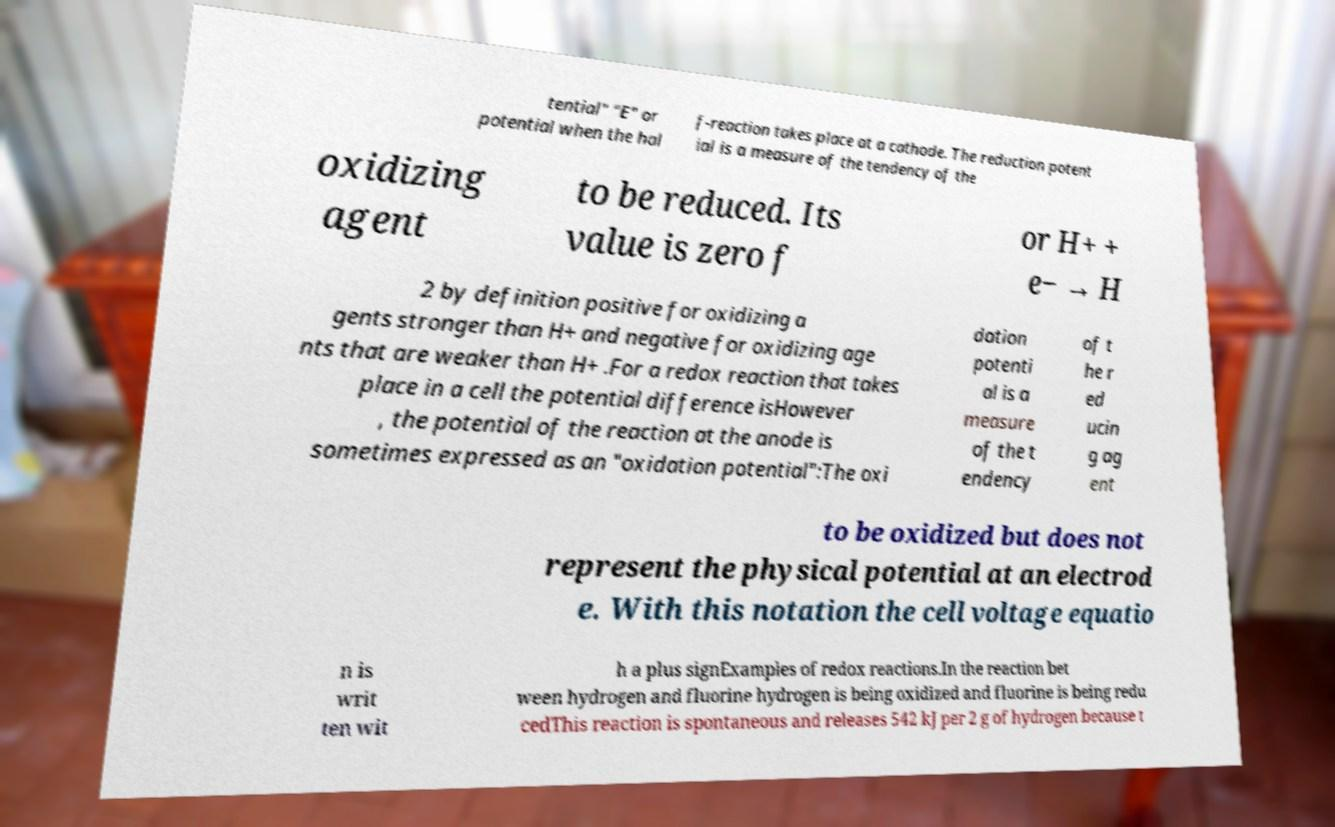Please read and relay the text visible in this image. What does it say? tential" "E" or potential when the hal f-reaction takes place at a cathode. The reduction potent ial is a measure of the tendency of the oxidizing agent to be reduced. Its value is zero f or H+ + e− → H 2 by definition positive for oxidizing a gents stronger than H+ and negative for oxidizing age nts that are weaker than H+ .For a redox reaction that takes place in a cell the potential difference isHowever , the potential of the reaction at the anode is sometimes expressed as an "oxidation potential":The oxi dation potenti al is a measure of the t endency of t he r ed ucin g ag ent to be oxidized but does not represent the physical potential at an electrod e. With this notation the cell voltage equatio n is writ ten wit h a plus signExamples of redox reactions.In the reaction bet ween hydrogen and fluorine hydrogen is being oxidized and fluorine is being redu cedThis reaction is spontaneous and releases 542 kJ per 2 g of hydrogen because t 